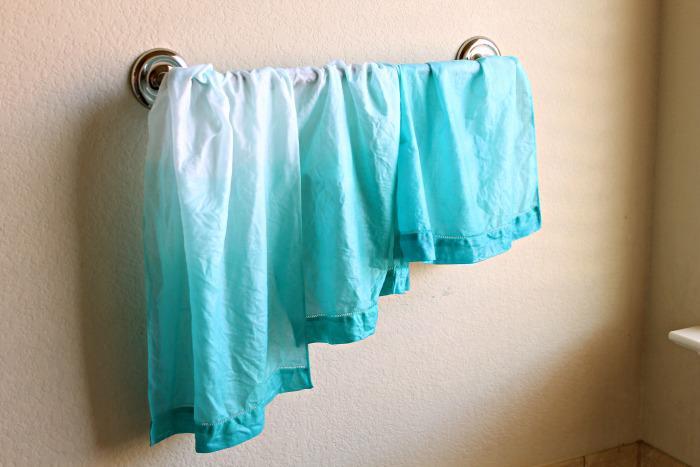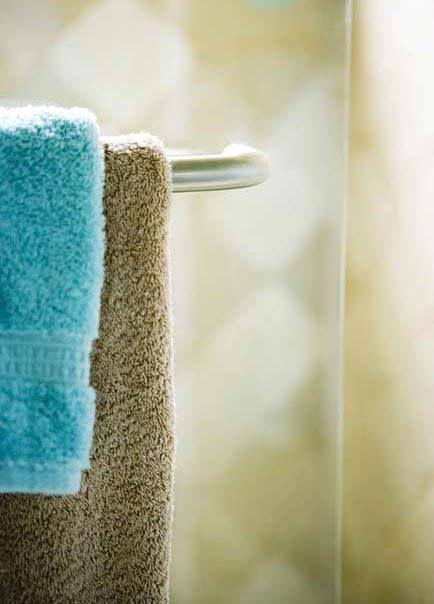The first image is the image on the left, the second image is the image on the right. For the images displayed, is the sentence "One image shows flat, folded, overlapping cloths, and the other image shows the folded edges of white towels, each with differnt colored stripes." factually correct? Answer yes or no. No. The first image is the image on the left, the second image is the image on the right. Analyze the images presented: Is the assertion "In at least one image there are three hanging pieces of fabric in the bathroom." valid? Answer yes or no. Yes. 